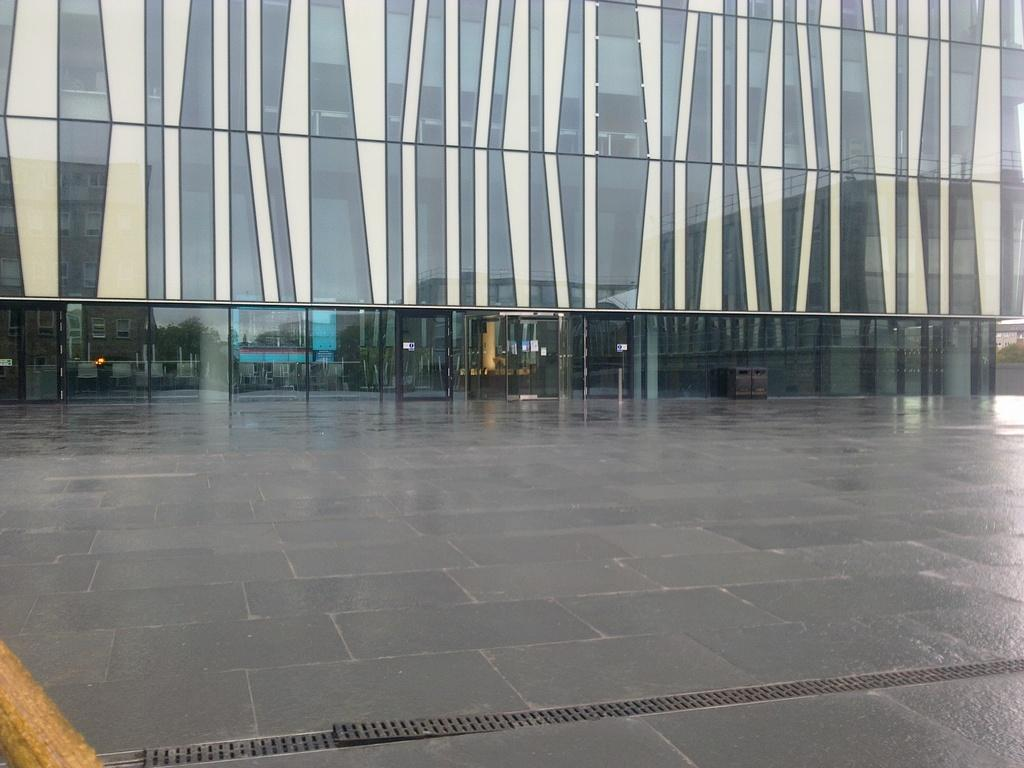What is visible at the bottom of the image? There is a floor visible in the image. What is the main structure in the image? There is a huge building in the image. What can be observed about the building's reflection? The building has a reflection of other buildings. What else can be seen in the reflection on the building? The reflection of trees is visible on the building. What part of the natural environment is visible in the reflection on the building? The sky is visible in the reflection on the building. Can you see any apples on the floor in the image? There are no apples visible on the floor in the image. Is there a wound on the building in the image? There is no wound present on the building in the image. 